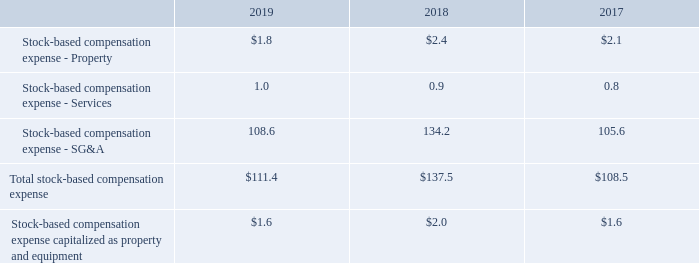AMERICAN TOWER CORPORATION AND SUBSIDIARIES NOTES TO CONSOLIDATED FINANCIAL STATEMENTS (Tabular amounts in millions, unless otherwise disclosed)
14. STOCK-BASED COMPENSATION
Summary of Stock-Based Compensation Plans—The Company maintains equity incentive plans that provide for the grant of stock-based awards to its directors, officers and employees. The 2007 Equity Incentive Plan, as amended (the “2007 Plan”), provides for the grant of non-qualified and incentive stock options, as well as restricted stock units, restricted stock and other stock-based awards. Exercise prices for non-qualified and incentive stock options are not less than the fair value of the underlying common stock on the date of grant. Equity awards typically vest ratably, generally over four years for RSUs and stock options and three years for PSUs. Stock options generally expire 10 years from the date of grant. As of December 31, 2019, the Company had the ability to grant stock-based awards with respect to an aggregate of 7.0 million shares of common stock under the 2007 Plan. In addition, the Company maintains an employee stock purchase plan (the “ESPP”) pursuant to which eligible employees may purchase shares of the Company’s common stock on the last day of each bi-annual offering period at a 15% discount from the lower of the closing market value on the first or last day of such offering period. The offering periods run from June 1 through November 30 and from December 1 through May 31 of each year.
During the years ended December 31, 2019, 2018 and 2017, the Company recorded and capitalized the following stock-based compensation expenses:
What was the Stock-based compensation expense - Property in 2019?
Answer scale should be: million. $1.8. Which years did the company record and capitalize stock-based compensation expenses? 2019, 2018, 2017. What was the Total stock-based compensation expense in 2017?
Answer scale should be: million. $108.5. How many years did Total stock-based compensation expense exceed $100 million? 2019##2018##2017
Answer: 3. How many years did Stock-based compensation expense - Services exceed $1 million? 2019
Answer: 1. What was the percentage change in Total stock-based compensation expense between 2018 and 2019?
Answer scale should be: percent. ($111.4-$137.5)/$137.5
Answer: -18.98. 